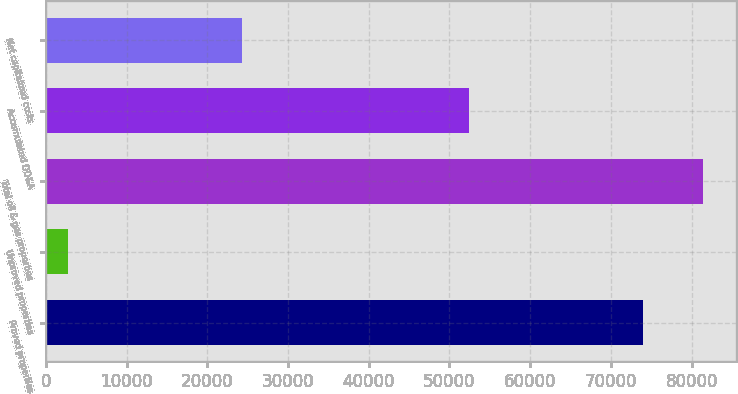Convert chart to OTSL. <chart><loc_0><loc_0><loc_500><loc_500><bar_chart><fcel>Proved properties<fcel>Unproved properties<fcel>Total oil & gas properties<fcel>Accumulated DD&A<fcel>Net capitalized costs<nl><fcel>73995<fcel>2791<fcel>81394.5<fcel>52461<fcel>24325<nl></chart> 